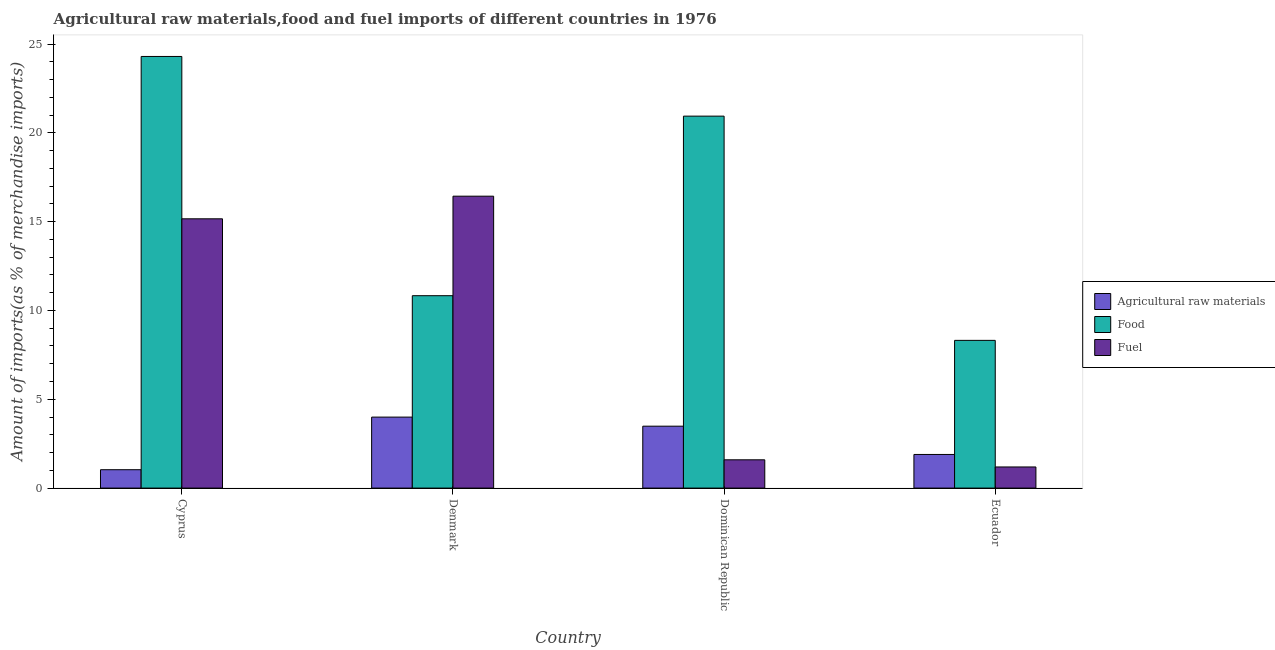How many groups of bars are there?
Your answer should be very brief. 4. What is the label of the 4th group of bars from the left?
Offer a very short reply. Ecuador. In how many cases, is the number of bars for a given country not equal to the number of legend labels?
Your response must be concise. 0. What is the percentage of raw materials imports in Ecuador?
Provide a succinct answer. 1.89. Across all countries, what is the maximum percentage of raw materials imports?
Keep it short and to the point. 4. Across all countries, what is the minimum percentage of food imports?
Keep it short and to the point. 8.32. In which country was the percentage of fuel imports maximum?
Provide a succinct answer. Denmark. In which country was the percentage of food imports minimum?
Make the answer very short. Ecuador. What is the total percentage of food imports in the graph?
Make the answer very short. 64.39. What is the difference between the percentage of fuel imports in Dominican Republic and that in Ecuador?
Provide a succinct answer. 0.4. What is the difference between the percentage of fuel imports in Cyprus and the percentage of food imports in Dominican Republic?
Provide a short and direct response. -5.78. What is the average percentage of food imports per country?
Offer a very short reply. 16.1. What is the difference between the percentage of food imports and percentage of raw materials imports in Cyprus?
Your answer should be very brief. 23.26. In how many countries, is the percentage of food imports greater than 2 %?
Give a very brief answer. 4. What is the ratio of the percentage of food imports in Dominican Republic to that in Ecuador?
Your answer should be compact. 2.52. Is the percentage of food imports in Denmark less than that in Ecuador?
Provide a succinct answer. No. Is the difference between the percentage of fuel imports in Cyprus and Denmark greater than the difference between the percentage of food imports in Cyprus and Denmark?
Offer a terse response. No. What is the difference between the highest and the second highest percentage of raw materials imports?
Provide a succinct answer. 0.51. What is the difference between the highest and the lowest percentage of raw materials imports?
Your response must be concise. 2.96. Is the sum of the percentage of raw materials imports in Cyprus and Denmark greater than the maximum percentage of food imports across all countries?
Offer a terse response. No. What does the 1st bar from the left in Ecuador represents?
Keep it short and to the point. Agricultural raw materials. What does the 3rd bar from the right in Cyprus represents?
Provide a short and direct response. Agricultural raw materials. Are all the bars in the graph horizontal?
Ensure brevity in your answer.  No. How many countries are there in the graph?
Provide a short and direct response. 4. Are the values on the major ticks of Y-axis written in scientific E-notation?
Provide a short and direct response. No. Does the graph contain grids?
Provide a succinct answer. No. How many legend labels are there?
Your response must be concise. 3. How are the legend labels stacked?
Provide a short and direct response. Vertical. What is the title of the graph?
Your response must be concise. Agricultural raw materials,food and fuel imports of different countries in 1976. What is the label or title of the Y-axis?
Provide a succinct answer. Amount of imports(as % of merchandise imports). What is the Amount of imports(as % of merchandise imports) of Agricultural raw materials in Cyprus?
Your answer should be very brief. 1.03. What is the Amount of imports(as % of merchandise imports) in Food in Cyprus?
Your response must be concise. 24.3. What is the Amount of imports(as % of merchandise imports) of Fuel in Cyprus?
Ensure brevity in your answer.  15.16. What is the Amount of imports(as % of merchandise imports) of Agricultural raw materials in Denmark?
Offer a very short reply. 4. What is the Amount of imports(as % of merchandise imports) in Food in Denmark?
Ensure brevity in your answer.  10.83. What is the Amount of imports(as % of merchandise imports) in Fuel in Denmark?
Your answer should be very brief. 16.43. What is the Amount of imports(as % of merchandise imports) of Agricultural raw materials in Dominican Republic?
Offer a terse response. 3.49. What is the Amount of imports(as % of merchandise imports) in Food in Dominican Republic?
Provide a short and direct response. 20.94. What is the Amount of imports(as % of merchandise imports) in Fuel in Dominican Republic?
Ensure brevity in your answer.  1.59. What is the Amount of imports(as % of merchandise imports) in Agricultural raw materials in Ecuador?
Your answer should be very brief. 1.89. What is the Amount of imports(as % of merchandise imports) in Food in Ecuador?
Make the answer very short. 8.32. What is the Amount of imports(as % of merchandise imports) of Fuel in Ecuador?
Provide a succinct answer. 1.19. Across all countries, what is the maximum Amount of imports(as % of merchandise imports) of Agricultural raw materials?
Give a very brief answer. 4. Across all countries, what is the maximum Amount of imports(as % of merchandise imports) of Food?
Ensure brevity in your answer.  24.3. Across all countries, what is the maximum Amount of imports(as % of merchandise imports) in Fuel?
Your response must be concise. 16.43. Across all countries, what is the minimum Amount of imports(as % of merchandise imports) in Agricultural raw materials?
Your answer should be compact. 1.03. Across all countries, what is the minimum Amount of imports(as % of merchandise imports) of Food?
Keep it short and to the point. 8.32. Across all countries, what is the minimum Amount of imports(as % of merchandise imports) of Fuel?
Provide a succinct answer. 1.19. What is the total Amount of imports(as % of merchandise imports) in Agricultural raw materials in the graph?
Provide a succinct answer. 10.41. What is the total Amount of imports(as % of merchandise imports) of Food in the graph?
Offer a terse response. 64.39. What is the total Amount of imports(as % of merchandise imports) in Fuel in the graph?
Keep it short and to the point. 34.37. What is the difference between the Amount of imports(as % of merchandise imports) in Agricultural raw materials in Cyprus and that in Denmark?
Offer a terse response. -2.96. What is the difference between the Amount of imports(as % of merchandise imports) in Food in Cyprus and that in Denmark?
Your response must be concise. 13.47. What is the difference between the Amount of imports(as % of merchandise imports) in Fuel in Cyprus and that in Denmark?
Give a very brief answer. -1.27. What is the difference between the Amount of imports(as % of merchandise imports) in Agricultural raw materials in Cyprus and that in Dominican Republic?
Your answer should be very brief. -2.45. What is the difference between the Amount of imports(as % of merchandise imports) of Food in Cyprus and that in Dominican Republic?
Provide a succinct answer. 3.36. What is the difference between the Amount of imports(as % of merchandise imports) in Fuel in Cyprus and that in Dominican Republic?
Ensure brevity in your answer.  13.57. What is the difference between the Amount of imports(as % of merchandise imports) of Agricultural raw materials in Cyprus and that in Ecuador?
Provide a succinct answer. -0.86. What is the difference between the Amount of imports(as % of merchandise imports) in Food in Cyprus and that in Ecuador?
Offer a terse response. 15.98. What is the difference between the Amount of imports(as % of merchandise imports) of Fuel in Cyprus and that in Ecuador?
Keep it short and to the point. 13.97. What is the difference between the Amount of imports(as % of merchandise imports) in Agricultural raw materials in Denmark and that in Dominican Republic?
Your response must be concise. 0.51. What is the difference between the Amount of imports(as % of merchandise imports) of Food in Denmark and that in Dominican Republic?
Make the answer very short. -10.11. What is the difference between the Amount of imports(as % of merchandise imports) in Fuel in Denmark and that in Dominican Republic?
Keep it short and to the point. 14.84. What is the difference between the Amount of imports(as % of merchandise imports) of Agricultural raw materials in Denmark and that in Ecuador?
Ensure brevity in your answer.  2.1. What is the difference between the Amount of imports(as % of merchandise imports) of Food in Denmark and that in Ecuador?
Offer a terse response. 2.51. What is the difference between the Amount of imports(as % of merchandise imports) in Fuel in Denmark and that in Ecuador?
Offer a very short reply. 15.24. What is the difference between the Amount of imports(as % of merchandise imports) in Agricultural raw materials in Dominican Republic and that in Ecuador?
Give a very brief answer. 1.59. What is the difference between the Amount of imports(as % of merchandise imports) in Food in Dominican Republic and that in Ecuador?
Make the answer very short. 12.62. What is the difference between the Amount of imports(as % of merchandise imports) in Fuel in Dominican Republic and that in Ecuador?
Your response must be concise. 0.4. What is the difference between the Amount of imports(as % of merchandise imports) in Agricultural raw materials in Cyprus and the Amount of imports(as % of merchandise imports) in Food in Denmark?
Provide a short and direct response. -9.8. What is the difference between the Amount of imports(as % of merchandise imports) in Agricultural raw materials in Cyprus and the Amount of imports(as % of merchandise imports) in Fuel in Denmark?
Provide a short and direct response. -15.4. What is the difference between the Amount of imports(as % of merchandise imports) of Food in Cyprus and the Amount of imports(as % of merchandise imports) of Fuel in Denmark?
Give a very brief answer. 7.87. What is the difference between the Amount of imports(as % of merchandise imports) of Agricultural raw materials in Cyprus and the Amount of imports(as % of merchandise imports) of Food in Dominican Republic?
Give a very brief answer. -19.9. What is the difference between the Amount of imports(as % of merchandise imports) in Agricultural raw materials in Cyprus and the Amount of imports(as % of merchandise imports) in Fuel in Dominican Republic?
Provide a short and direct response. -0.56. What is the difference between the Amount of imports(as % of merchandise imports) in Food in Cyprus and the Amount of imports(as % of merchandise imports) in Fuel in Dominican Republic?
Your answer should be compact. 22.71. What is the difference between the Amount of imports(as % of merchandise imports) in Agricultural raw materials in Cyprus and the Amount of imports(as % of merchandise imports) in Food in Ecuador?
Your answer should be compact. -7.28. What is the difference between the Amount of imports(as % of merchandise imports) of Agricultural raw materials in Cyprus and the Amount of imports(as % of merchandise imports) of Fuel in Ecuador?
Provide a short and direct response. -0.15. What is the difference between the Amount of imports(as % of merchandise imports) in Food in Cyprus and the Amount of imports(as % of merchandise imports) in Fuel in Ecuador?
Your answer should be compact. 23.11. What is the difference between the Amount of imports(as % of merchandise imports) of Agricultural raw materials in Denmark and the Amount of imports(as % of merchandise imports) of Food in Dominican Republic?
Provide a short and direct response. -16.94. What is the difference between the Amount of imports(as % of merchandise imports) of Agricultural raw materials in Denmark and the Amount of imports(as % of merchandise imports) of Fuel in Dominican Republic?
Offer a terse response. 2.4. What is the difference between the Amount of imports(as % of merchandise imports) of Food in Denmark and the Amount of imports(as % of merchandise imports) of Fuel in Dominican Republic?
Your answer should be compact. 9.24. What is the difference between the Amount of imports(as % of merchandise imports) of Agricultural raw materials in Denmark and the Amount of imports(as % of merchandise imports) of Food in Ecuador?
Offer a very short reply. -4.32. What is the difference between the Amount of imports(as % of merchandise imports) in Agricultural raw materials in Denmark and the Amount of imports(as % of merchandise imports) in Fuel in Ecuador?
Your answer should be compact. 2.81. What is the difference between the Amount of imports(as % of merchandise imports) in Food in Denmark and the Amount of imports(as % of merchandise imports) in Fuel in Ecuador?
Your response must be concise. 9.64. What is the difference between the Amount of imports(as % of merchandise imports) in Agricultural raw materials in Dominican Republic and the Amount of imports(as % of merchandise imports) in Food in Ecuador?
Provide a short and direct response. -4.83. What is the difference between the Amount of imports(as % of merchandise imports) in Agricultural raw materials in Dominican Republic and the Amount of imports(as % of merchandise imports) in Fuel in Ecuador?
Give a very brief answer. 2.3. What is the difference between the Amount of imports(as % of merchandise imports) in Food in Dominican Republic and the Amount of imports(as % of merchandise imports) in Fuel in Ecuador?
Your answer should be very brief. 19.75. What is the average Amount of imports(as % of merchandise imports) of Agricultural raw materials per country?
Make the answer very short. 2.6. What is the average Amount of imports(as % of merchandise imports) in Food per country?
Provide a short and direct response. 16.1. What is the average Amount of imports(as % of merchandise imports) in Fuel per country?
Ensure brevity in your answer.  8.59. What is the difference between the Amount of imports(as % of merchandise imports) in Agricultural raw materials and Amount of imports(as % of merchandise imports) in Food in Cyprus?
Your answer should be compact. -23.26. What is the difference between the Amount of imports(as % of merchandise imports) of Agricultural raw materials and Amount of imports(as % of merchandise imports) of Fuel in Cyprus?
Give a very brief answer. -14.12. What is the difference between the Amount of imports(as % of merchandise imports) in Food and Amount of imports(as % of merchandise imports) in Fuel in Cyprus?
Give a very brief answer. 9.14. What is the difference between the Amount of imports(as % of merchandise imports) in Agricultural raw materials and Amount of imports(as % of merchandise imports) in Food in Denmark?
Ensure brevity in your answer.  -6.83. What is the difference between the Amount of imports(as % of merchandise imports) in Agricultural raw materials and Amount of imports(as % of merchandise imports) in Fuel in Denmark?
Provide a short and direct response. -12.44. What is the difference between the Amount of imports(as % of merchandise imports) in Food and Amount of imports(as % of merchandise imports) in Fuel in Denmark?
Provide a short and direct response. -5.6. What is the difference between the Amount of imports(as % of merchandise imports) of Agricultural raw materials and Amount of imports(as % of merchandise imports) of Food in Dominican Republic?
Keep it short and to the point. -17.45. What is the difference between the Amount of imports(as % of merchandise imports) of Agricultural raw materials and Amount of imports(as % of merchandise imports) of Fuel in Dominican Republic?
Give a very brief answer. 1.89. What is the difference between the Amount of imports(as % of merchandise imports) in Food and Amount of imports(as % of merchandise imports) in Fuel in Dominican Republic?
Make the answer very short. 19.35. What is the difference between the Amount of imports(as % of merchandise imports) of Agricultural raw materials and Amount of imports(as % of merchandise imports) of Food in Ecuador?
Offer a very short reply. -6.42. What is the difference between the Amount of imports(as % of merchandise imports) in Agricultural raw materials and Amount of imports(as % of merchandise imports) in Fuel in Ecuador?
Give a very brief answer. 0.7. What is the difference between the Amount of imports(as % of merchandise imports) of Food and Amount of imports(as % of merchandise imports) of Fuel in Ecuador?
Give a very brief answer. 7.13. What is the ratio of the Amount of imports(as % of merchandise imports) of Agricultural raw materials in Cyprus to that in Denmark?
Your response must be concise. 0.26. What is the ratio of the Amount of imports(as % of merchandise imports) of Food in Cyprus to that in Denmark?
Ensure brevity in your answer.  2.24. What is the ratio of the Amount of imports(as % of merchandise imports) in Fuel in Cyprus to that in Denmark?
Make the answer very short. 0.92. What is the ratio of the Amount of imports(as % of merchandise imports) of Agricultural raw materials in Cyprus to that in Dominican Republic?
Ensure brevity in your answer.  0.3. What is the ratio of the Amount of imports(as % of merchandise imports) of Food in Cyprus to that in Dominican Republic?
Offer a terse response. 1.16. What is the ratio of the Amount of imports(as % of merchandise imports) in Fuel in Cyprus to that in Dominican Republic?
Offer a terse response. 9.52. What is the ratio of the Amount of imports(as % of merchandise imports) of Agricultural raw materials in Cyprus to that in Ecuador?
Keep it short and to the point. 0.55. What is the ratio of the Amount of imports(as % of merchandise imports) in Food in Cyprus to that in Ecuador?
Your answer should be very brief. 2.92. What is the ratio of the Amount of imports(as % of merchandise imports) in Fuel in Cyprus to that in Ecuador?
Offer a terse response. 12.74. What is the ratio of the Amount of imports(as % of merchandise imports) of Agricultural raw materials in Denmark to that in Dominican Republic?
Ensure brevity in your answer.  1.15. What is the ratio of the Amount of imports(as % of merchandise imports) of Food in Denmark to that in Dominican Republic?
Your answer should be compact. 0.52. What is the ratio of the Amount of imports(as % of merchandise imports) in Fuel in Denmark to that in Dominican Republic?
Your answer should be very brief. 10.32. What is the ratio of the Amount of imports(as % of merchandise imports) of Agricultural raw materials in Denmark to that in Ecuador?
Provide a succinct answer. 2.11. What is the ratio of the Amount of imports(as % of merchandise imports) of Food in Denmark to that in Ecuador?
Make the answer very short. 1.3. What is the ratio of the Amount of imports(as % of merchandise imports) in Fuel in Denmark to that in Ecuador?
Your answer should be compact. 13.81. What is the ratio of the Amount of imports(as % of merchandise imports) of Agricultural raw materials in Dominican Republic to that in Ecuador?
Make the answer very short. 1.84. What is the ratio of the Amount of imports(as % of merchandise imports) in Food in Dominican Republic to that in Ecuador?
Ensure brevity in your answer.  2.52. What is the ratio of the Amount of imports(as % of merchandise imports) of Fuel in Dominican Republic to that in Ecuador?
Offer a very short reply. 1.34. What is the difference between the highest and the second highest Amount of imports(as % of merchandise imports) in Agricultural raw materials?
Provide a short and direct response. 0.51. What is the difference between the highest and the second highest Amount of imports(as % of merchandise imports) in Food?
Give a very brief answer. 3.36. What is the difference between the highest and the second highest Amount of imports(as % of merchandise imports) in Fuel?
Ensure brevity in your answer.  1.27. What is the difference between the highest and the lowest Amount of imports(as % of merchandise imports) in Agricultural raw materials?
Offer a very short reply. 2.96. What is the difference between the highest and the lowest Amount of imports(as % of merchandise imports) of Food?
Offer a terse response. 15.98. What is the difference between the highest and the lowest Amount of imports(as % of merchandise imports) of Fuel?
Provide a succinct answer. 15.24. 